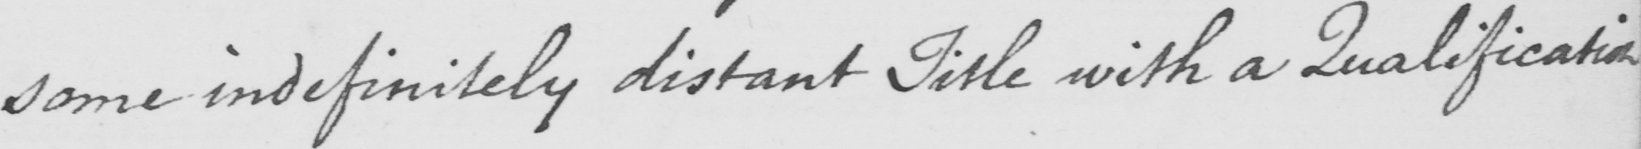Please transcribe the handwritten text in this image. some indefinitely distant Title with a Qualification 